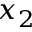<formula> <loc_0><loc_0><loc_500><loc_500>x _ { 2 }</formula> 